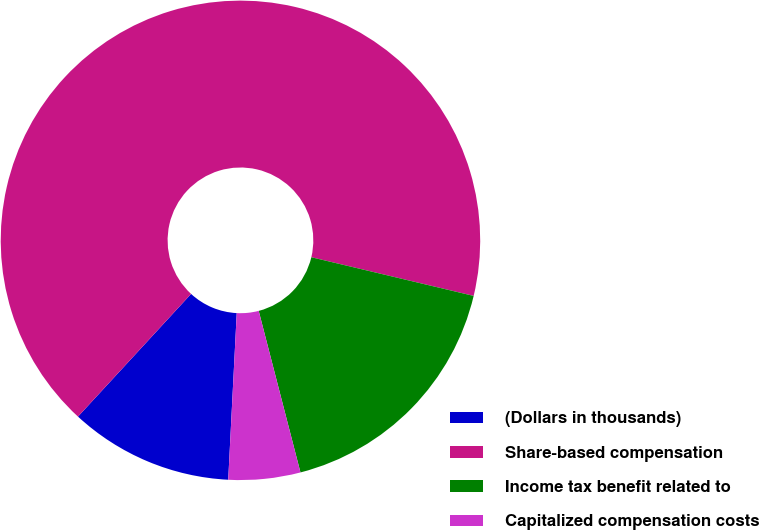<chart> <loc_0><loc_0><loc_500><loc_500><pie_chart><fcel>(Dollars in thousands)<fcel>Share-based compensation<fcel>Income tax benefit related to<fcel>Capitalized compensation costs<nl><fcel>11.04%<fcel>66.87%<fcel>17.25%<fcel>4.84%<nl></chart> 